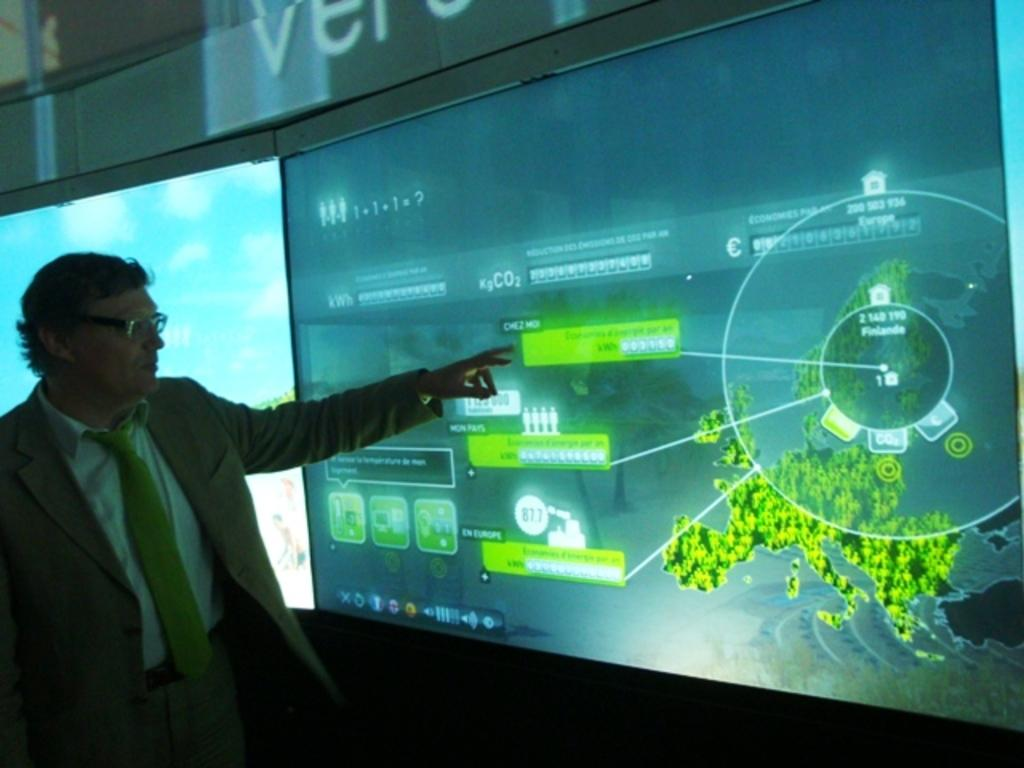<image>
Write a terse but informative summary of the picture. Person is pointing at a screen which says CO2 on it. 